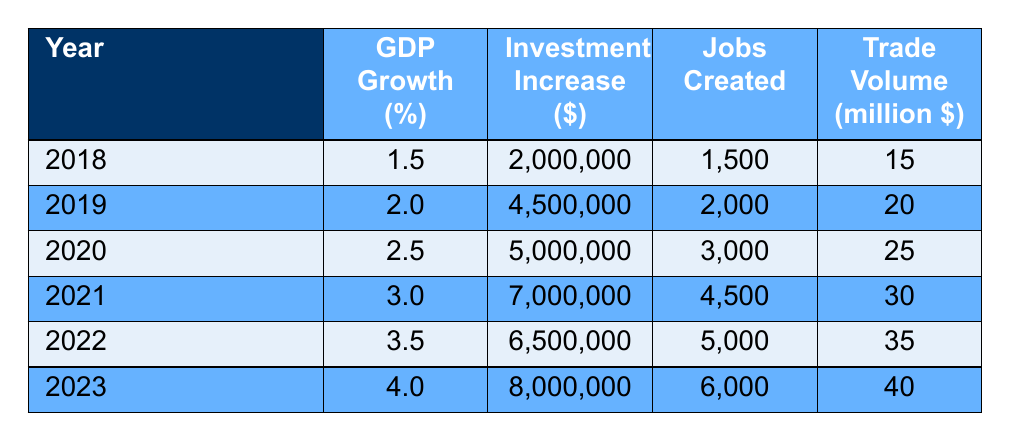What was the GDP growth percentage in 2020? According to the table, the GDP growth percentage for the year 2020 is directly listed, which is 2.5%.
Answer: 2.5 In which year did the highest number of jobs get created? By reviewing the 'Jobs Created' column, the year 2023 shows the highest number with 6000 jobs created.
Answer: 2023 What is the total increase in investment from 2018 to 2023? To find the total increase in investment, I sum the values from each year: 2000000 + 4500000 + 5000000 + 7000000 + 6500000 + 8000000 = 33500000.
Answer: 33500000 Was there an increase in GDP growth percentage every year from 2018 to 2023? Looking at the GDP growth percentages for each year, they are consecutively increasing: 1.5, 2.0, 2.5, 3.0, 3.5, and 4.0, confirming a consistent increase.
Answer: Yes What was the average trade volume in million USD from 2018 to 2023? To compute the average trade volume, first sum all the trade volumes: 15 + 20 + 25 + 30 + 35 + 40 = 165. Then divide by the number of years (6): 165 / 6 = 27.5.
Answer: 27.5 Which peace initiative had the lowest increase in investment? By comparing the 'Investment Increase' values across the years, 2018 had the lowest at 2000000.
Answer: 2018 Did any year show a GDP growth percentage of more than 3%? Checking the GDP growth percentages, the years 2021, 2022, and 2023 have values above 3%, making the statement true.
Answer: Yes What was the difference in trade volume between 2022 and 2023? The trade volume for 2022 is 35 million USD and for 2023 is 40 million USD. The difference is 40 - 35 = 5 million USD.
Answer: 5 million USD 